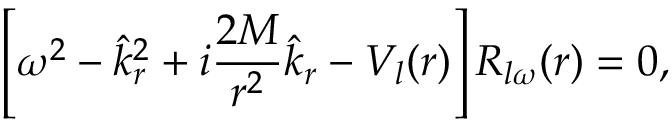Convert formula to latex. <formula><loc_0><loc_0><loc_500><loc_500>\left [ \omega ^ { 2 } - \hat { k } _ { r } ^ { 2 } + i { \frac { 2 M } { r ^ { 2 } } } \hat { k } _ { r } - V _ { l } ( r ) \right ] R _ { l \omega } ( r ) = 0 ,</formula> 